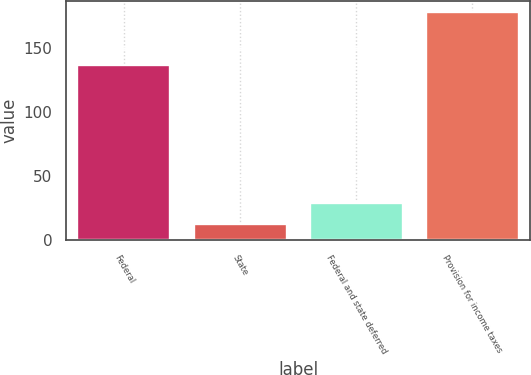Convert chart. <chart><loc_0><loc_0><loc_500><loc_500><bar_chart><fcel>Federal<fcel>State<fcel>Federal and state deferred<fcel>Provision for income taxes<nl><fcel>136.8<fcel>12.1<fcel>28.68<fcel>177.9<nl></chart> 